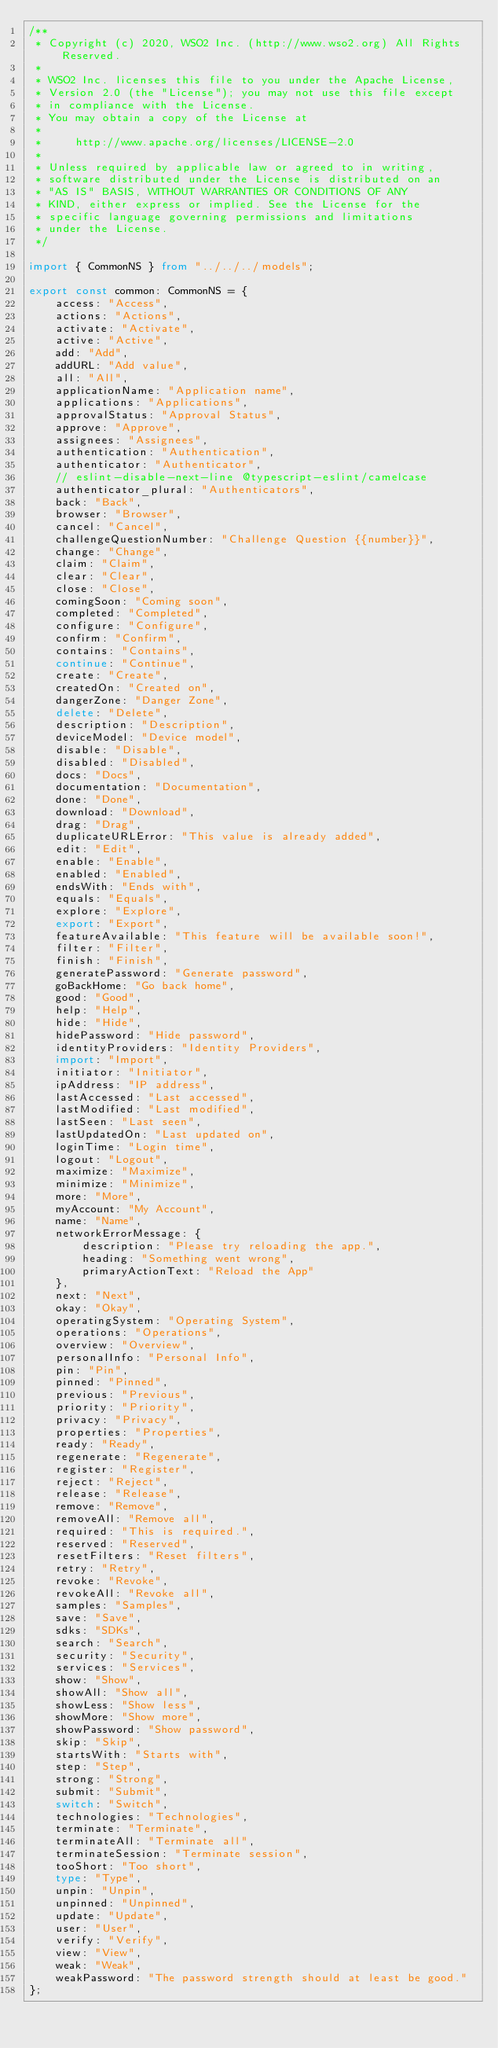<code> <loc_0><loc_0><loc_500><loc_500><_TypeScript_>/**
 * Copyright (c) 2020, WSO2 Inc. (http://www.wso2.org) All Rights Reserved.
 *
 * WSO2 Inc. licenses this file to you under the Apache License,
 * Version 2.0 (the "License"); you may not use this file except
 * in compliance with the License.
 * You may obtain a copy of the License at
 *
 *     http://www.apache.org/licenses/LICENSE-2.0
 *
 * Unless required by applicable law or agreed to in writing,
 * software distributed under the License is distributed on an
 * "AS IS" BASIS, WITHOUT WARRANTIES OR CONDITIONS OF ANY
 * KIND, either express or implied. See the License for the
 * specific language governing permissions and limitations
 * under the License.
 */

import { CommonNS } from "../../../models";

export const common: CommonNS = {
    access: "Access",
    actions: "Actions",
    activate: "Activate",
    active: "Active",
    add: "Add",
    addURL: "Add value",
    all: "All",
    applicationName: "Application name",
    applications: "Applications",
    approvalStatus: "Approval Status",
    approve: "Approve",
    assignees: "Assignees",
    authentication: "Authentication",
    authenticator: "Authenticator",
    // eslint-disable-next-line @typescript-eslint/camelcase
    authenticator_plural: "Authenticators",
    back: "Back",
    browser: "Browser",
    cancel: "Cancel",
    challengeQuestionNumber: "Challenge Question {{number}}",
    change: "Change",
    claim: "Claim",
    clear: "Clear",
    close: "Close",
    comingSoon: "Coming soon",
    completed: "Completed",
    configure: "Configure",
    confirm: "Confirm",
    contains: "Contains",
    continue: "Continue",
    create: "Create",
    createdOn: "Created on",
    dangerZone: "Danger Zone",
    delete: "Delete",
    description: "Description",
    deviceModel: "Device model",
    disable: "Disable",
    disabled: "Disabled",
    docs: "Docs",
    documentation: "Documentation",
    done: "Done",
    download: "Download",
    drag: "Drag",
    duplicateURLError: "This value is already added",
    edit: "Edit",
    enable: "Enable",
    enabled: "Enabled",
    endsWith: "Ends with",
    equals: "Equals",
    explore: "Explore",
    export: "Export",
    featureAvailable: "This feature will be available soon!",
    filter: "Filter",
    finish: "Finish",
    generatePassword: "Generate password",
    goBackHome: "Go back home",
    good: "Good",
    help: "Help",
    hide: "Hide",
    hidePassword: "Hide password",
    identityProviders: "Identity Providers",
    import: "Import",
    initiator: "Initiator",
    ipAddress: "IP address",
    lastAccessed: "Last accessed",
    lastModified: "Last modified",
    lastSeen: "Last seen",
    lastUpdatedOn: "Last updated on",
    loginTime: "Login time",
    logout: "Logout",
    maximize: "Maximize",
    minimize: "Minimize",
    more: "More",
    myAccount: "My Account",
    name: "Name",
    networkErrorMessage: {
        description: "Please try reloading the app.",
        heading: "Something went wrong",
        primaryActionText: "Reload the App"
    },
    next: "Next",
    okay: "Okay",
    operatingSystem: "Operating System",
    operations: "Operations",
    overview: "Overview",
    personalInfo: "Personal Info",
    pin: "Pin",
    pinned: "Pinned",
    previous: "Previous",
    priority: "Priority",
    privacy: "Privacy",
    properties: "Properties",
    ready: "Ready",
    regenerate: "Regenerate",
    register: "Register",
    reject: "Reject",
    release: "Release",
    remove: "Remove",
    removeAll: "Remove all",
    required: "This is required.",
    reserved: "Reserved",
    resetFilters: "Reset filters",
    retry: "Retry",
    revoke: "Revoke",
    revokeAll: "Revoke all",
    samples: "Samples",
    save: "Save",
    sdks: "SDKs",
    search: "Search",
    security: "Security",
    services: "Services",
    show: "Show",
    showAll: "Show all",
    showLess: "Show less",
    showMore: "Show more",
    showPassword: "Show password",
    skip: "Skip",
    startsWith: "Starts with",
    step: "Step",
    strong: "Strong",
    submit: "Submit",
    switch: "Switch",
    technologies: "Technologies",
    terminate: "Terminate",
    terminateAll: "Terminate all",
    terminateSession: "Terminate session",
    tooShort: "Too short",
    type: "Type",
    unpin: "Unpin",
    unpinned: "Unpinned",
    update: "Update",
    user: "User",
    verify: "Verify",
    view: "View",
    weak: "Weak",
    weakPassword: "The password strength should at least be good."
};
</code> 